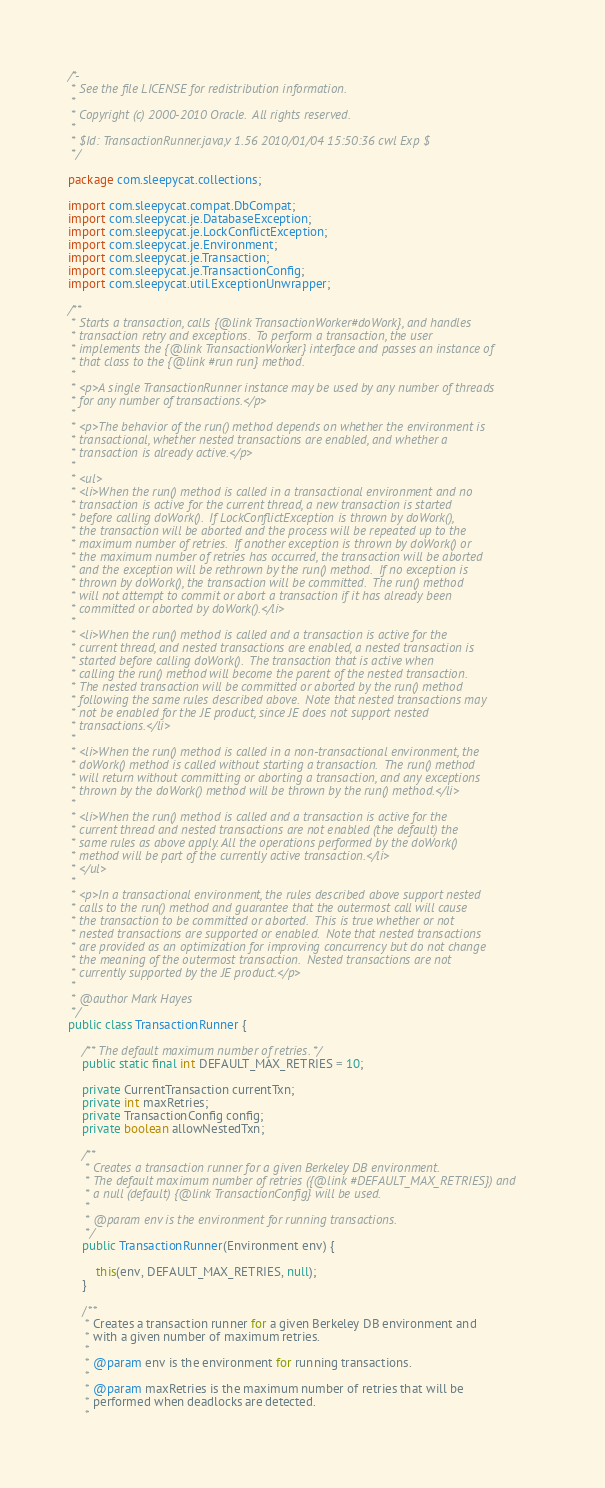Convert code to text. <code><loc_0><loc_0><loc_500><loc_500><_Java_>/*-
 * See the file LICENSE for redistribution information.
 *
 * Copyright (c) 2000-2010 Oracle.  All rights reserved.
 *
 * $Id: TransactionRunner.java,v 1.56 2010/01/04 15:50:36 cwl Exp $
 */

package com.sleepycat.collections;

import com.sleepycat.compat.DbCompat;
import com.sleepycat.je.DatabaseException;
import com.sleepycat.je.LockConflictException;
import com.sleepycat.je.Environment;
import com.sleepycat.je.Transaction;
import com.sleepycat.je.TransactionConfig;
import com.sleepycat.util.ExceptionUnwrapper;

/**
 * Starts a transaction, calls {@link TransactionWorker#doWork}, and handles
 * transaction retry and exceptions.  To perform a transaction, the user
 * implements the {@link TransactionWorker} interface and passes an instance of
 * that class to the {@link #run run} method.
 *
 * <p>A single TransactionRunner instance may be used by any number of threads
 * for any number of transactions.</p>
 *
 * <p>The behavior of the run() method depends on whether the environment is
 * transactional, whether nested transactions are enabled, and whether a
 * transaction is already active.</p>
 *
 * <ul>
 * <li>When the run() method is called in a transactional environment and no
 * transaction is active for the current thread, a new transaction is started
 * before calling doWork().  If LockConflictException is thrown by doWork(),
 * the transaction will be aborted and the process will be repeated up to the
 * maximum number of retries.  If another exception is thrown by doWork() or
 * the maximum number of retries has occurred, the transaction will be aborted
 * and the exception will be rethrown by the run() method.  If no exception is
 * thrown by doWork(), the transaction will be committed.  The run() method
 * will not attempt to commit or abort a transaction if it has already been
 * committed or aborted by doWork().</li>
 *
 * <li>When the run() method is called and a transaction is active for the
 * current thread, and nested transactions are enabled, a nested transaction is
 * started before calling doWork().  The transaction that is active when
 * calling the run() method will become the parent of the nested transaction.
 * The nested transaction will be committed or aborted by the run() method
 * following the same rules described above.  Note that nested transactions may
 * not be enabled for the JE product, since JE does not support nested
 * transactions.</li>
 *
 * <li>When the run() method is called in a non-transactional environment, the
 * doWork() method is called without starting a transaction.  The run() method
 * will return without committing or aborting a transaction, and any exceptions
 * thrown by the doWork() method will be thrown by the run() method.</li>
 *
 * <li>When the run() method is called and a transaction is active for the
 * current thread and nested transactions are not enabled (the default) the
 * same rules as above apply. All the operations performed by the doWork()
 * method will be part of the currently active transaction.</li>
 * </ul>
 *
 * <p>In a transactional environment, the rules described above support nested
 * calls to the run() method and guarantee that the outermost call will cause
 * the transaction to be committed or aborted.  This is true whether or not
 * nested transactions are supported or enabled.  Note that nested transactions
 * are provided as an optimization for improving concurrency but do not change
 * the meaning of the outermost transaction.  Nested transactions are not
 * currently supported by the JE product.</p>
 *
 * @author Mark Hayes
 */
public class TransactionRunner {

    /** The default maximum number of retries. */
    public static final int DEFAULT_MAX_RETRIES = 10;

    private CurrentTransaction currentTxn;
    private int maxRetries;
    private TransactionConfig config;
    private boolean allowNestedTxn;

    /**
     * Creates a transaction runner for a given Berkeley DB environment.
     * The default maximum number of retries ({@link #DEFAULT_MAX_RETRIES}) and
     * a null (default) {@link TransactionConfig} will be used.
     *
     * @param env is the environment for running transactions.
     */
    public TransactionRunner(Environment env) {

        this(env, DEFAULT_MAX_RETRIES, null);
    }

    /**
     * Creates a transaction runner for a given Berkeley DB environment and
     * with a given number of maximum retries.
     *
     * @param env is the environment for running transactions.
     *
     * @param maxRetries is the maximum number of retries that will be
     * performed when deadlocks are detected.
     *</code> 